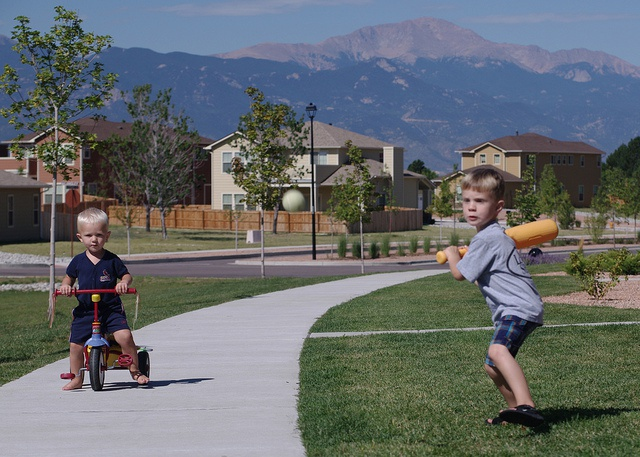Describe the objects in this image and their specific colors. I can see people in gray, darkgray, and black tones, people in gray, black, maroon, and navy tones, bicycle in gray, black, maroon, and olive tones, baseball bat in gray, tan, maroon, and brown tones, and sports ball in gray, darkgray, and beige tones in this image. 